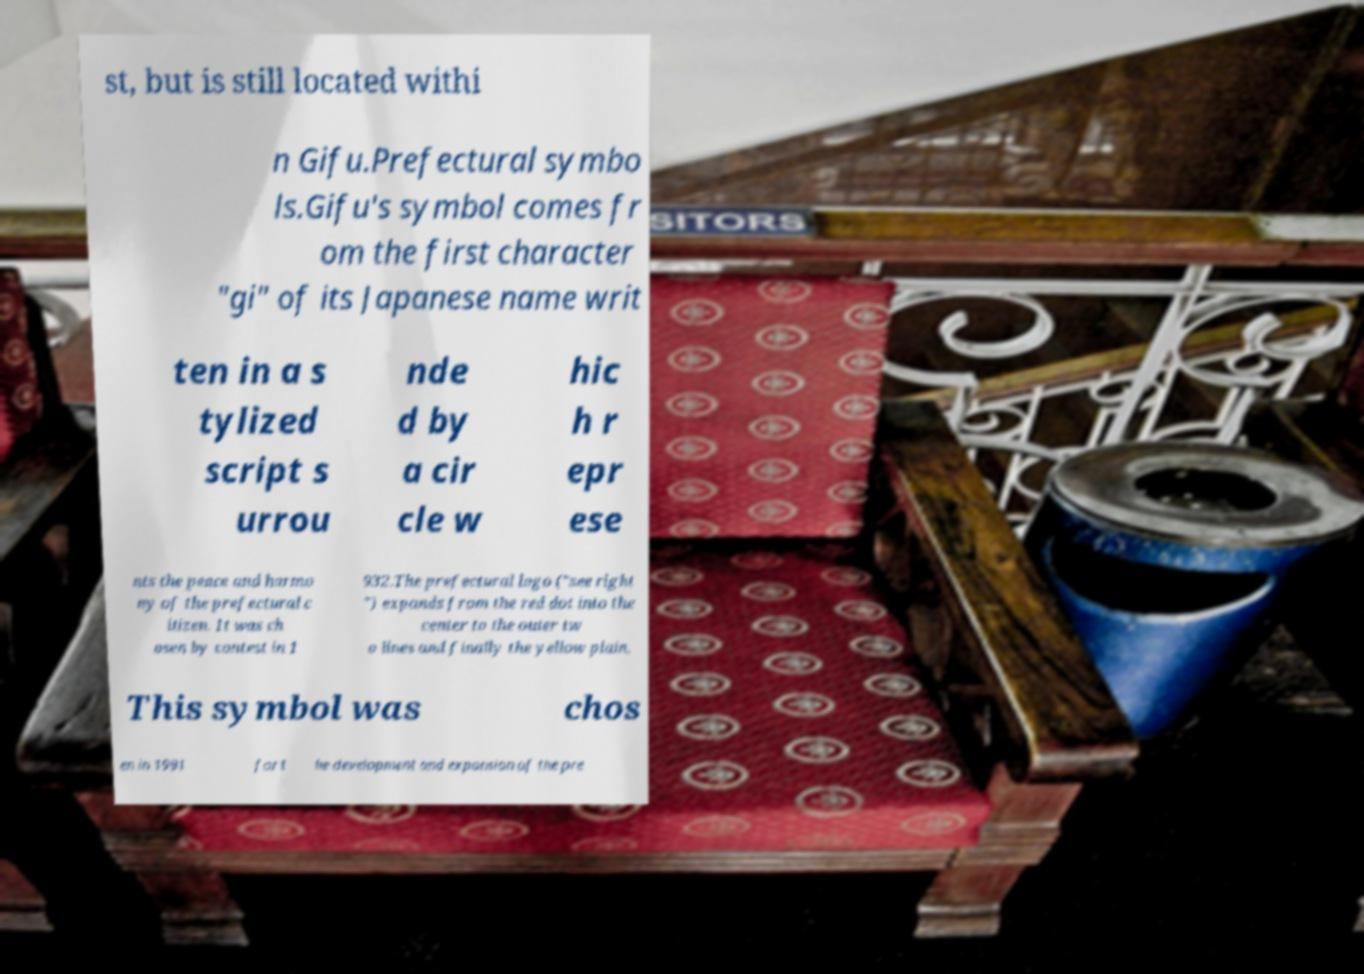There's text embedded in this image that I need extracted. Can you transcribe it verbatim? st, but is still located withi n Gifu.Prefectural symbo ls.Gifu's symbol comes fr om the first character "gi" of its Japanese name writ ten in a s tylized script s urrou nde d by a cir cle w hic h r epr ese nts the peace and harmo ny of the prefectural c itizen. It was ch osen by contest in 1 932.The prefectural logo ("see right ") expands from the red dot into the center to the outer tw o lines and finally the yellow plain. This symbol was chos en in 1991 for t he development and expansion of the pre 